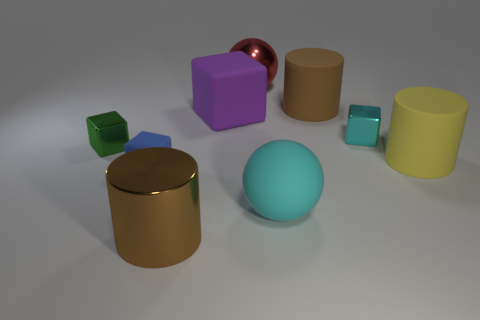Is the red sphere made of the same material as the green cube?
Offer a very short reply. Yes. Is the number of metal cylinders less than the number of large cylinders?
Provide a short and direct response. Yes. Does the yellow thing have the same shape as the tiny cyan shiny thing?
Make the answer very short. No. The tiny rubber cube has what color?
Make the answer very short. Blue. How many other things are there of the same material as the big cyan thing?
Your response must be concise. 4. How many blue objects are either big rubber cubes or tiny shiny objects?
Your response must be concise. 0. There is a big rubber object on the left side of the big red sphere; does it have the same shape as the tiny object that is on the left side of the tiny blue block?
Offer a terse response. Yes. Does the tiny rubber block have the same color as the small metallic block on the right side of the big brown metallic cylinder?
Ensure brevity in your answer.  No. Is the color of the small shiny thing left of the red shiny ball the same as the big matte ball?
Your answer should be compact. No. What number of things are small cyan metal cubes or metallic things in front of the red shiny object?
Your answer should be compact. 3. 